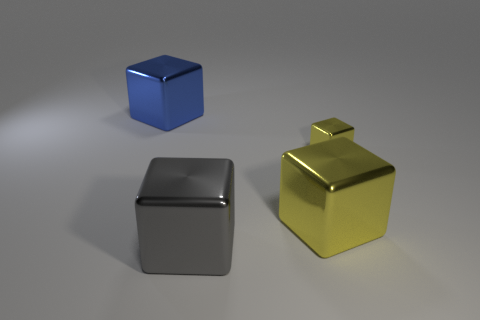How many other objects are the same shape as the large blue metal thing?
Ensure brevity in your answer.  3. The large thing that is in front of the yellow object on the left side of the tiny cube is made of what material?
Make the answer very short. Metal. Is there anything else that is the same size as the blue metal object?
Your answer should be very brief. Yes. Are the gray thing and the object that is to the right of the large yellow thing made of the same material?
Your response must be concise. Yes. The object that is in front of the small yellow metallic thing and right of the big gray block is made of what material?
Your response must be concise. Metal. What is the color of the block that is in front of the yellow thing in front of the small block?
Keep it short and to the point. Gray. What material is the yellow block in front of the tiny metal thing?
Provide a succinct answer. Metal. Is the number of tiny purple matte objects less than the number of large metallic things?
Offer a very short reply. Yes. Does the tiny thing have the same shape as the big blue object that is behind the tiny thing?
Ensure brevity in your answer.  Yes. There is a shiny object that is to the left of the small object and behind the large yellow object; what shape is it?
Ensure brevity in your answer.  Cube. 